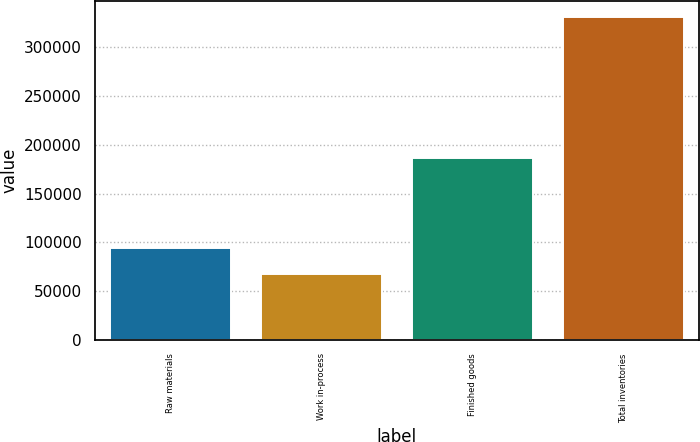Convert chart to OTSL. <chart><loc_0><loc_0><loc_500><loc_500><bar_chart><fcel>Raw materials<fcel>Work in-process<fcel>Finished goods<fcel>Total inventories<nl><fcel>93819.2<fcel>67502<fcel>186237<fcel>330674<nl></chart> 